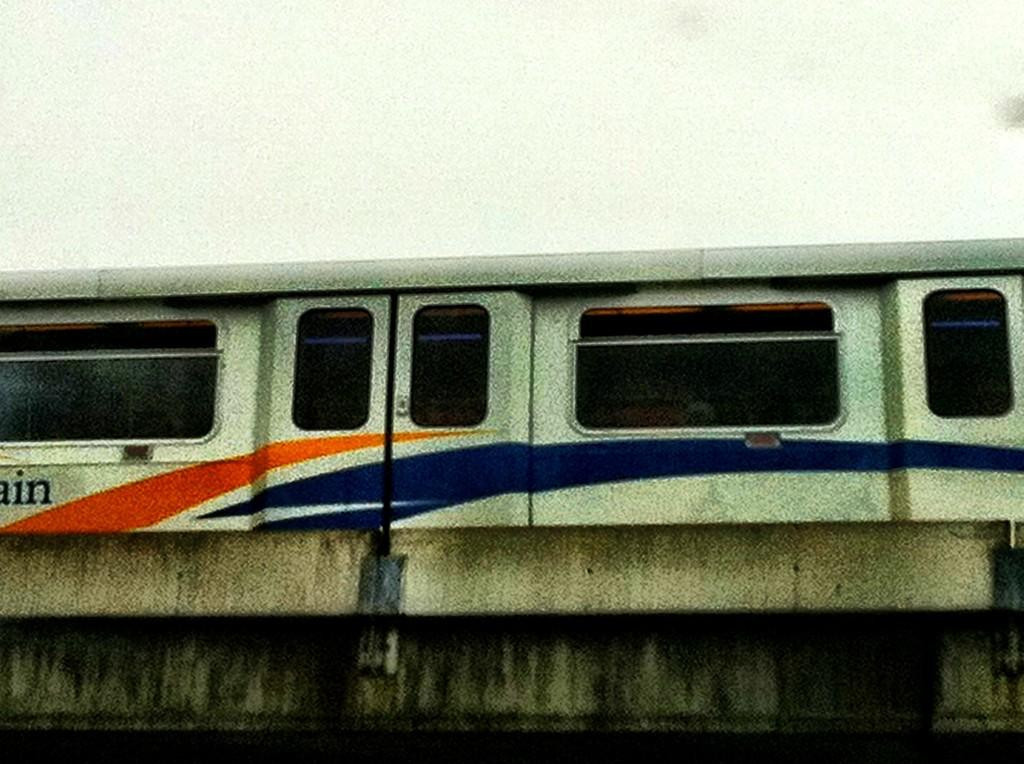What is the main subject of the image? The main subject of the image is a train. Where is the train located in the image? The train is on a bridge in the image. What type of trousers is the fireman wearing while collecting taxes in the image? There is no fireman, tax collection, or trousers present in the image; it only features a train on a bridge. 